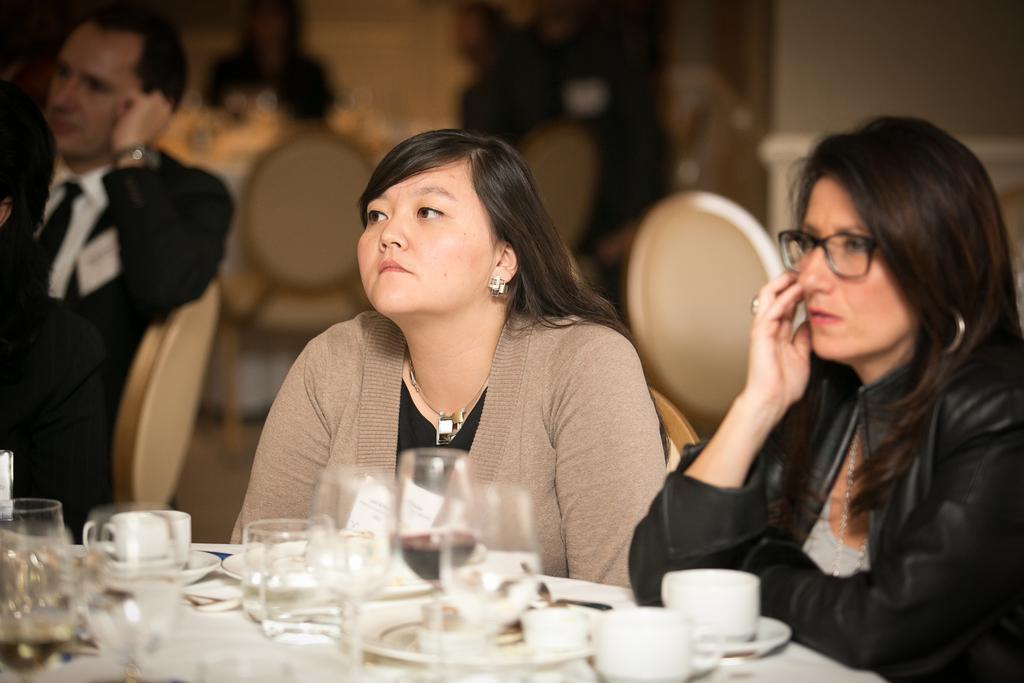Please provide a concise description of this image. In the picture I can see two women and men are sitting on chairs. Here I can see a table on which I can see some glasses, cups and other objects. The background of the image is blurred. 